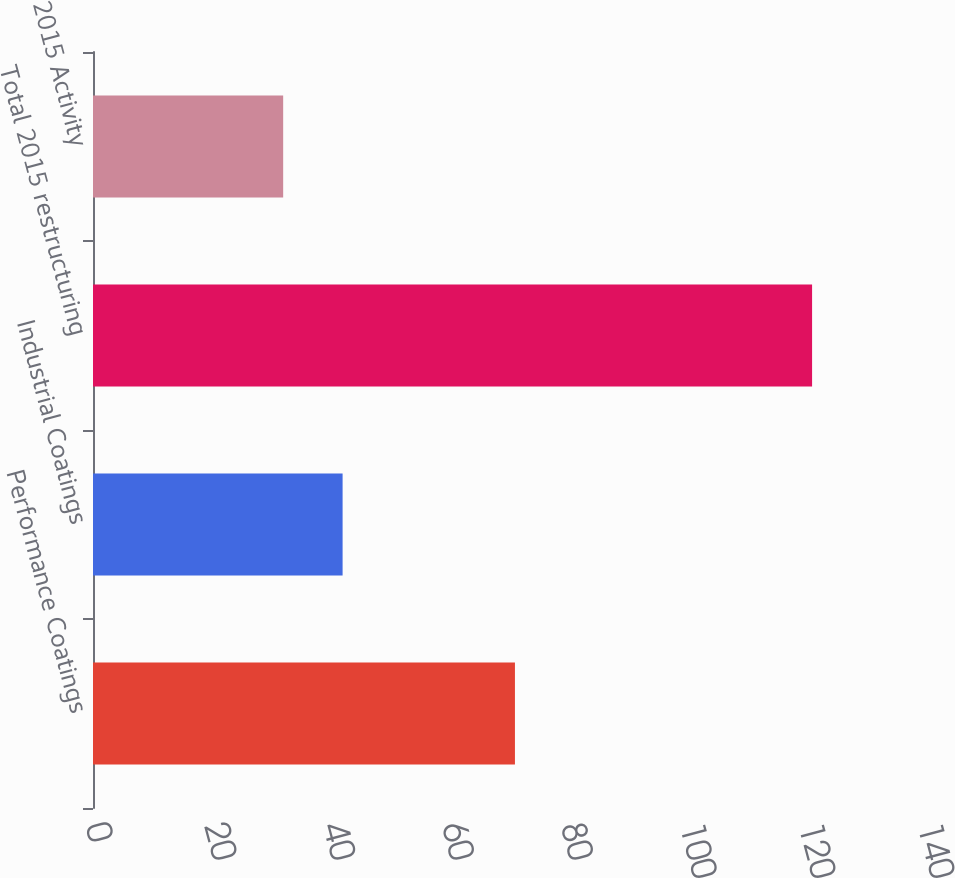Convert chart. <chart><loc_0><loc_0><loc_500><loc_500><bar_chart><fcel>Performance Coatings<fcel>Industrial Coatings<fcel>Total 2015 restructuring<fcel>2015 Activity<nl><fcel>71<fcel>42<fcel>121<fcel>32<nl></chart> 